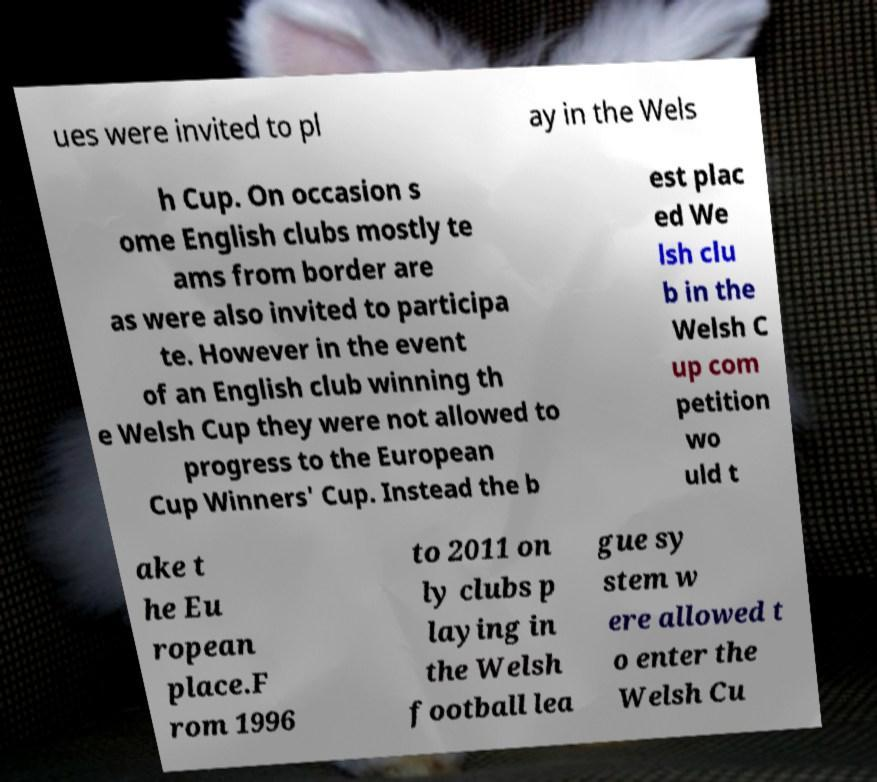Could you assist in decoding the text presented in this image and type it out clearly? ues were invited to pl ay in the Wels h Cup. On occasion s ome English clubs mostly te ams from border are as were also invited to participa te. However in the event of an English club winning th e Welsh Cup they were not allowed to progress to the European Cup Winners' Cup. Instead the b est plac ed We lsh clu b in the Welsh C up com petition wo uld t ake t he Eu ropean place.F rom 1996 to 2011 on ly clubs p laying in the Welsh football lea gue sy stem w ere allowed t o enter the Welsh Cu 